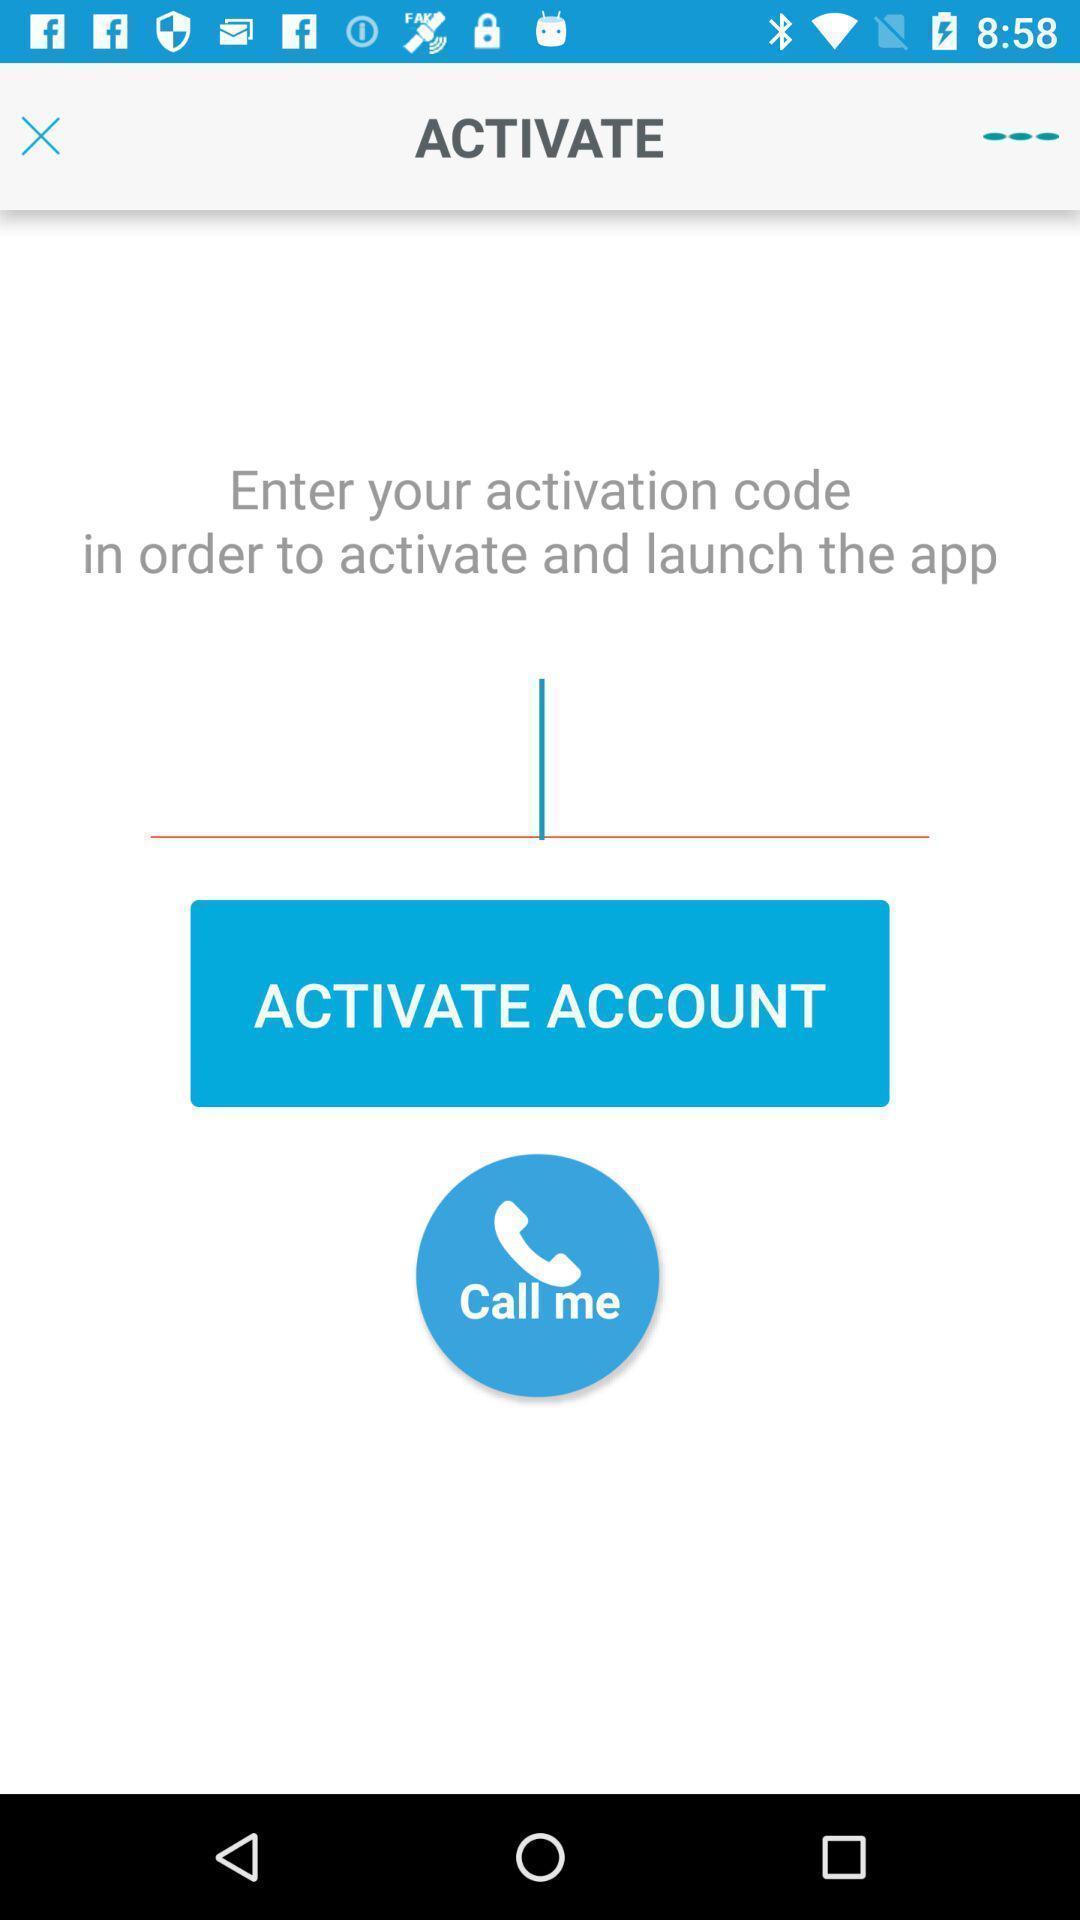What can you discern from this picture? Screen page displaying code to enter. 